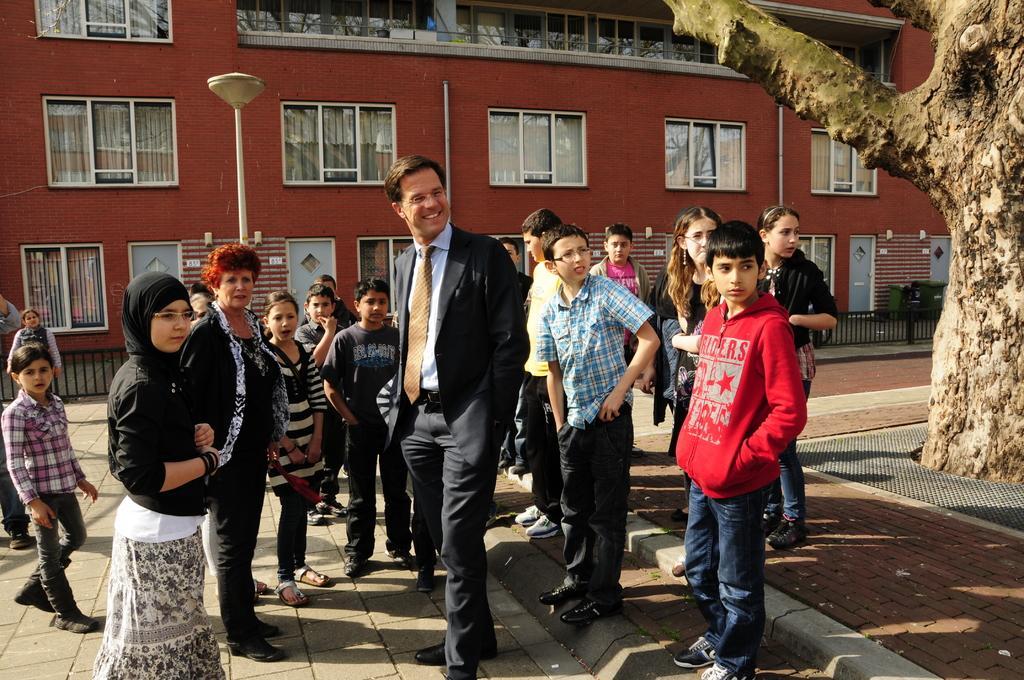Could you give a brief overview of what you see in this image? In this picture we can see some people are standing, in the background there is a building, we can see windows and glasses of the building, on the right side we can see a tree and dustbins, there is a pole and a light in the middle. 